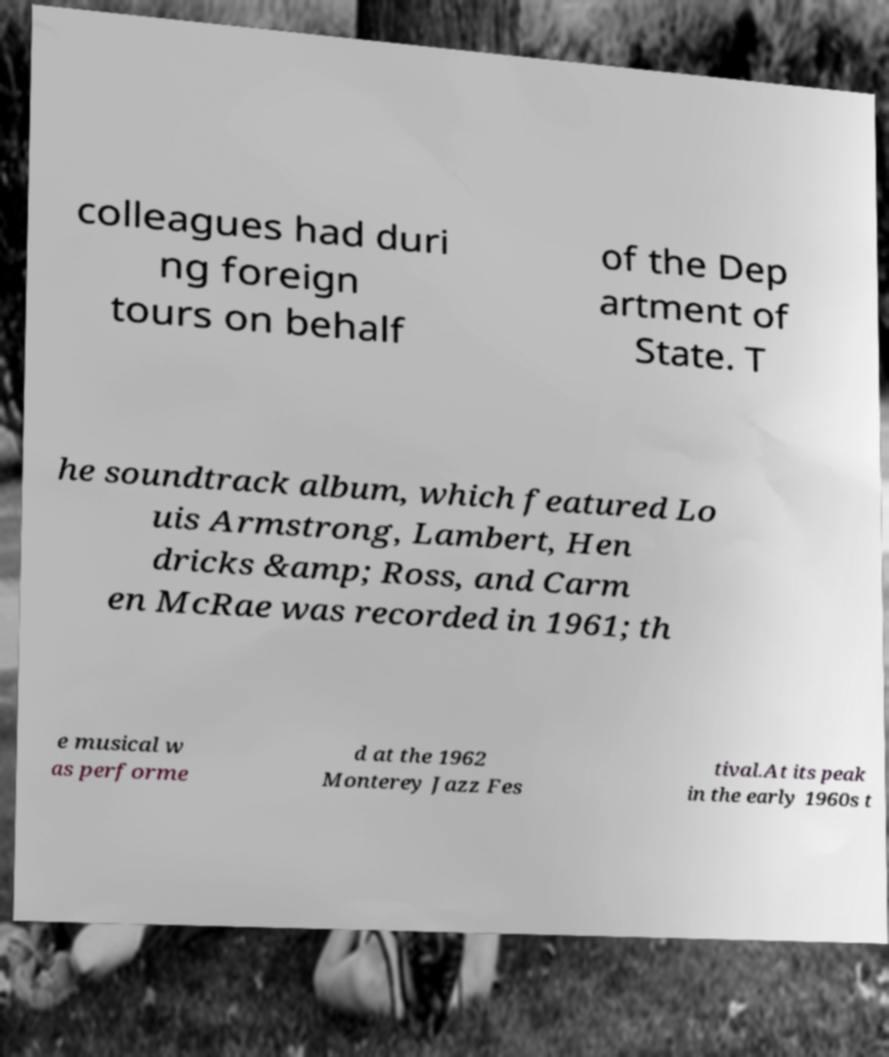For documentation purposes, I need the text within this image transcribed. Could you provide that? colleagues had duri ng foreign tours on behalf of the Dep artment of State. T he soundtrack album, which featured Lo uis Armstrong, Lambert, Hen dricks &amp; Ross, and Carm en McRae was recorded in 1961; th e musical w as performe d at the 1962 Monterey Jazz Fes tival.At its peak in the early 1960s t 